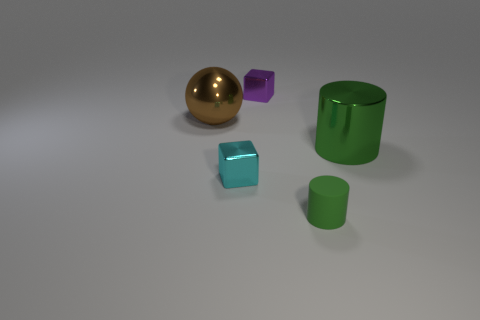Add 1 small spheres. How many objects exist? 6 Subtract all cyan blocks. How many blocks are left? 1 Subtract all spheres. How many objects are left? 4 Subtract 1 blocks. How many blocks are left? 1 Subtract all tiny green blocks. Subtract all tiny purple shiny things. How many objects are left? 4 Add 5 purple cubes. How many purple cubes are left? 6 Add 1 tiny brown spheres. How many tiny brown spheres exist? 1 Subtract 0 gray spheres. How many objects are left? 5 Subtract all green blocks. Subtract all yellow cylinders. How many blocks are left? 2 